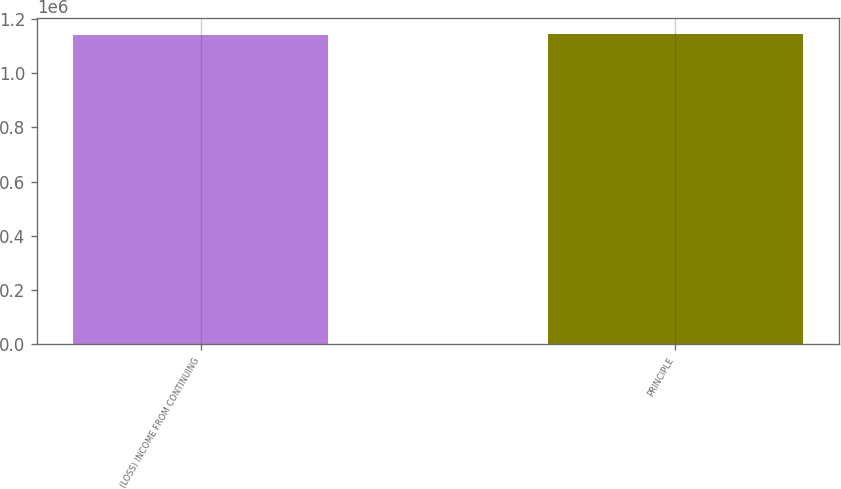Convert chart to OTSL. <chart><loc_0><loc_0><loc_500><loc_500><bar_chart><fcel>(LOSS) INCOME FROM CONTINUING<fcel>PRINCIPLE<nl><fcel>1.14188e+06<fcel>1.14465e+06<nl></chart> 